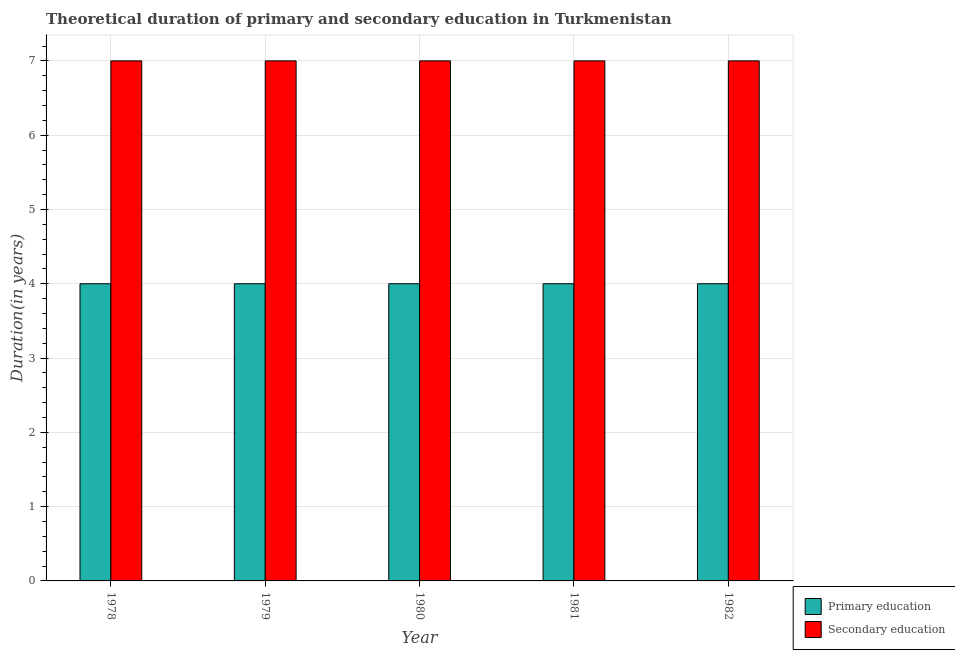Are the number of bars per tick equal to the number of legend labels?
Provide a short and direct response. Yes. How many bars are there on the 2nd tick from the left?
Ensure brevity in your answer.  2. What is the label of the 2nd group of bars from the left?
Your response must be concise. 1979. What is the duration of secondary education in 1978?
Your response must be concise. 7. Across all years, what is the maximum duration of secondary education?
Provide a succinct answer. 7. Across all years, what is the minimum duration of primary education?
Your response must be concise. 4. In which year was the duration of secondary education maximum?
Offer a very short reply. 1978. In which year was the duration of primary education minimum?
Your answer should be compact. 1978. What is the total duration of primary education in the graph?
Keep it short and to the point. 20. What is the difference between the duration of primary education in 1979 and that in 1980?
Your answer should be very brief. 0. What is the difference between the duration of secondary education in 1978 and the duration of primary education in 1982?
Offer a terse response. 0. In the year 1981, what is the difference between the duration of secondary education and duration of primary education?
Offer a very short reply. 0. In how many years, is the duration of primary education greater than 0.6000000000000001 years?
Your response must be concise. 5. What is the difference between the highest and the second highest duration of primary education?
Provide a succinct answer. 0. In how many years, is the duration of primary education greater than the average duration of primary education taken over all years?
Give a very brief answer. 0. What does the 1st bar from the left in 1981 represents?
Provide a short and direct response. Primary education. How many bars are there?
Give a very brief answer. 10. How many years are there in the graph?
Make the answer very short. 5. What is the difference between two consecutive major ticks on the Y-axis?
Make the answer very short. 1. How many legend labels are there?
Your response must be concise. 2. What is the title of the graph?
Your response must be concise. Theoretical duration of primary and secondary education in Turkmenistan. What is the label or title of the X-axis?
Keep it short and to the point. Year. What is the label or title of the Y-axis?
Give a very brief answer. Duration(in years). What is the Duration(in years) in Primary education in 1979?
Your answer should be compact. 4. What is the Duration(in years) of Primary education in 1980?
Your answer should be compact. 4. What is the Duration(in years) of Secondary education in 1980?
Offer a very short reply. 7. What is the Duration(in years) in Primary education in 1981?
Offer a very short reply. 4. What is the Duration(in years) in Secondary education in 1982?
Ensure brevity in your answer.  7. Across all years, what is the maximum Duration(in years) in Primary education?
Ensure brevity in your answer.  4. What is the difference between the Duration(in years) of Secondary education in 1978 and that in 1979?
Provide a short and direct response. 0. What is the difference between the Duration(in years) in Secondary education in 1978 and that in 1980?
Provide a succinct answer. 0. What is the difference between the Duration(in years) of Primary education in 1978 and that in 1981?
Make the answer very short. 0. What is the difference between the Duration(in years) of Primary education in 1979 and that in 1980?
Your answer should be very brief. 0. What is the difference between the Duration(in years) of Secondary education in 1979 and that in 1980?
Your response must be concise. 0. What is the difference between the Duration(in years) of Primary education in 1979 and that in 1981?
Offer a very short reply. 0. What is the difference between the Duration(in years) of Primary education in 1980 and that in 1981?
Make the answer very short. 0. What is the difference between the Duration(in years) in Secondary education in 1980 and that in 1982?
Ensure brevity in your answer.  0. What is the difference between the Duration(in years) in Primary education in 1981 and that in 1982?
Give a very brief answer. 0. What is the difference between the Duration(in years) of Primary education in 1978 and the Duration(in years) of Secondary education in 1980?
Ensure brevity in your answer.  -3. What is the difference between the Duration(in years) of Primary education in 1978 and the Duration(in years) of Secondary education in 1982?
Give a very brief answer. -3. What is the difference between the Duration(in years) in Primary education in 1979 and the Duration(in years) in Secondary education in 1982?
Ensure brevity in your answer.  -3. What is the difference between the Duration(in years) of Primary education in 1980 and the Duration(in years) of Secondary education in 1981?
Give a very brief answer. -3. What is the difference between the Duration(in years) of Primary education in 1981 and the Duration(in years) of Secondary education in 1982?
Your answer should be compact. -3. In the year 1980, what is the difference between the Duration(in years) of Primary education and Duration(in years) of Secondary education?
Give a very brief answer. -3. In the year 1981, what is the difference between the Duration(in years) in Primary education and Duration(in years) in Secondary education?
Provide a succinct answer. -3. In the year 1982, what is the difference between the Duration(in years) in Primary education and Duration(in years) in Secondary education?
Make the answer very short. -3. What is the ratio of the Duration(in years) in Primary education in 1978 to that in 1979?
Make the answer very short. 1. What is the ratio of the Duration(in years) in Primary education in 1978 to that in 1981?
Give a very brief answer. 1. What is the ratio of the Duration(in years) in Secondary education in 1979 to that in 1980?
Provide a succinct answer. 1. What is the ratio of the Duration(in years) of Secondary education in 1979 to that in 1981?
Your response must be concise. 1. What is the ratio of the Duration(in years) of Primary education in 1979 to that in 1982?
Provide a short and direct response. 1. What is the ratio of the Duration(in years) of Secondary education in 1979 to that in 1982?
Provide a succinct answer. 1. What is the ratio of the Duration(in years) in Primary education in 1981 to that in 1982?
Keep it short and to the point. 1. What is the difference between the highest and the second highest Duration(in years) in Secondary education?
Offer a very short reply. 0. 